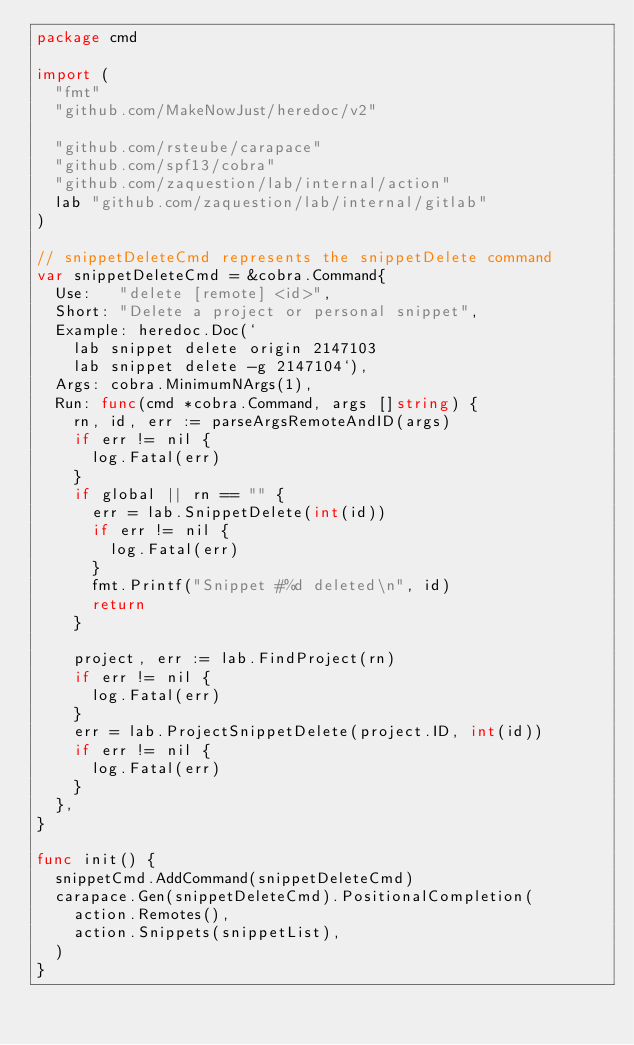<code> <loc_0><loc_0><loc_500><loc_500><_Go_>package cmd

import (
	"fmt"
	"github.com/MakeNowJust/heredoc/v2"

	"github.com/rsteube/carapace"
	"github.com/spf13/cobra"
	"github.com/zaquestion/lab/internal/action"
	lab "github.com/zaquestion/lab/internal/gitlab"
)

// snippetDeleteCmd represents the snippetDelete command
var snippetDeleteCmd = &cobra.Command{
	Use:   "delete [remote] <id>",
	Short: "Delete a project or personal snippet",
	Example: heredoc.Doc(`
		lab snippet delete origin 2147103
		lab snippet delete -g 2147104`),
	Args: cobra.MinimumNArgs(1),
	Run: func(cmd *cobra.Command, args []string) {
		rn, id, err := parseArgsRemoteAndID(args)
		if err != nil {
			log.Fatal(err)
		}
		if global || rn == "" {
			err = lab.SnippetDelete(int(id))
			if err != nil {
				log.Fatal(err)
			}
			fmt.Printf("Snippet #%d deleted\n", id)
			return
		}

		project, err := lab.FindProject(rn)
		if err != nil {
			log.Fatal(err)
		}
		err = lab.ProjectSnippetDelete(project.ID, int(id))
		if err != nil {
			log.Fatal(err)
		}
	},
}

func init() {
	snippetCmd.AddCommand(snippetDeleteCmd)
	carapace.Gen(snippetDeleteCmd).PositionalCompletion(
		action.Remotes(),
		action.Snippets(snippetList),
	)
}
</code> 